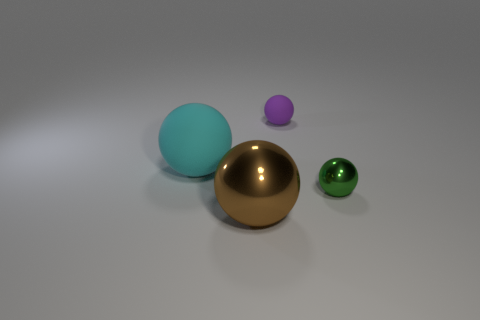Add 2 matte spheres. How many objects exist? 6 Subtract all purple spheres. How many spheres are left? 3 Subtract all green shiny balls. How many balls are left? 3 Subtract 4 balls. How many balls are left? 0 Add 4 tiny rubber balls. How many tiny rubber balls are left? 5 Add 3 tiny purple rubber things. How many tiny purple rubber things exist? 4 Subtract 0 red cylinders. How many objects are left? 4 Subtract all purple balls. Subtract all red blocks. How many balls are left? 3 Subtract all purple blocks. How many purple balls are left? 1 Subtract all green shiny spheres. Subtract all small purple rubber objects. How many objects are left? 2 